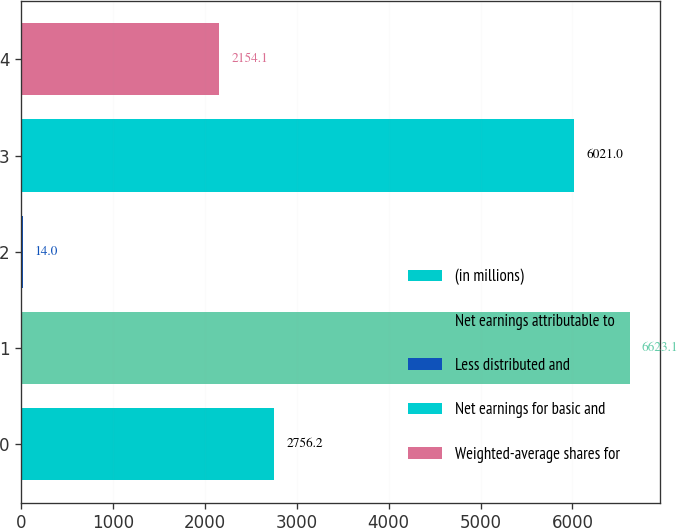Convert chart. <chart><loc_0><loc_0><loc_500><loc_500><bar_chart><fcel>(in millions)<fcel>Net earnings attributable to<fcel>Less distributed and<fcel>Net earnings for basic and<fcel>Weighted-average shares for<nl><fcel>2756.2<fcel>6623.1<fcel>14<fcel>6021<fcel>2154.1<nl></chart> 